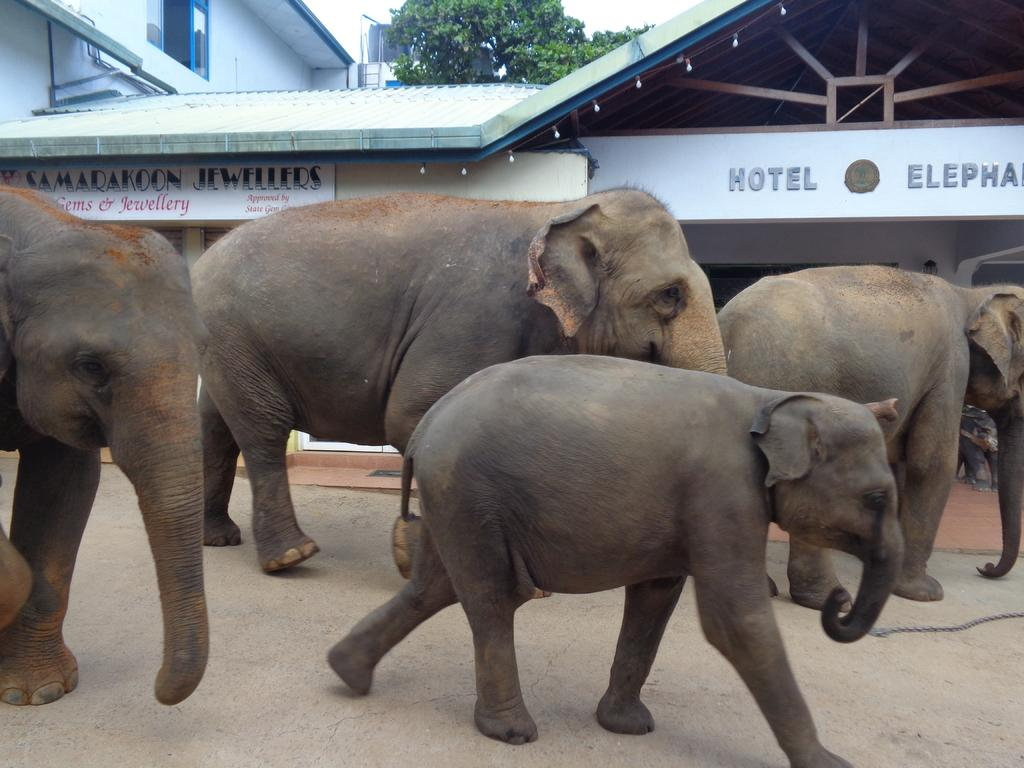What animals are present in the image? There are elephants in the image. What direction are the elephants moving in? The elephants are walking towards the right. What can be seen in the background of the image? There are buildings and trees in the background of the image. What feature do the buildings have? The buildings have name boards. What type of crib is visible in the image? There is no crib present in the image. How are the elephants being coached in the image? The image does not show any coaching or training of the elephants. 